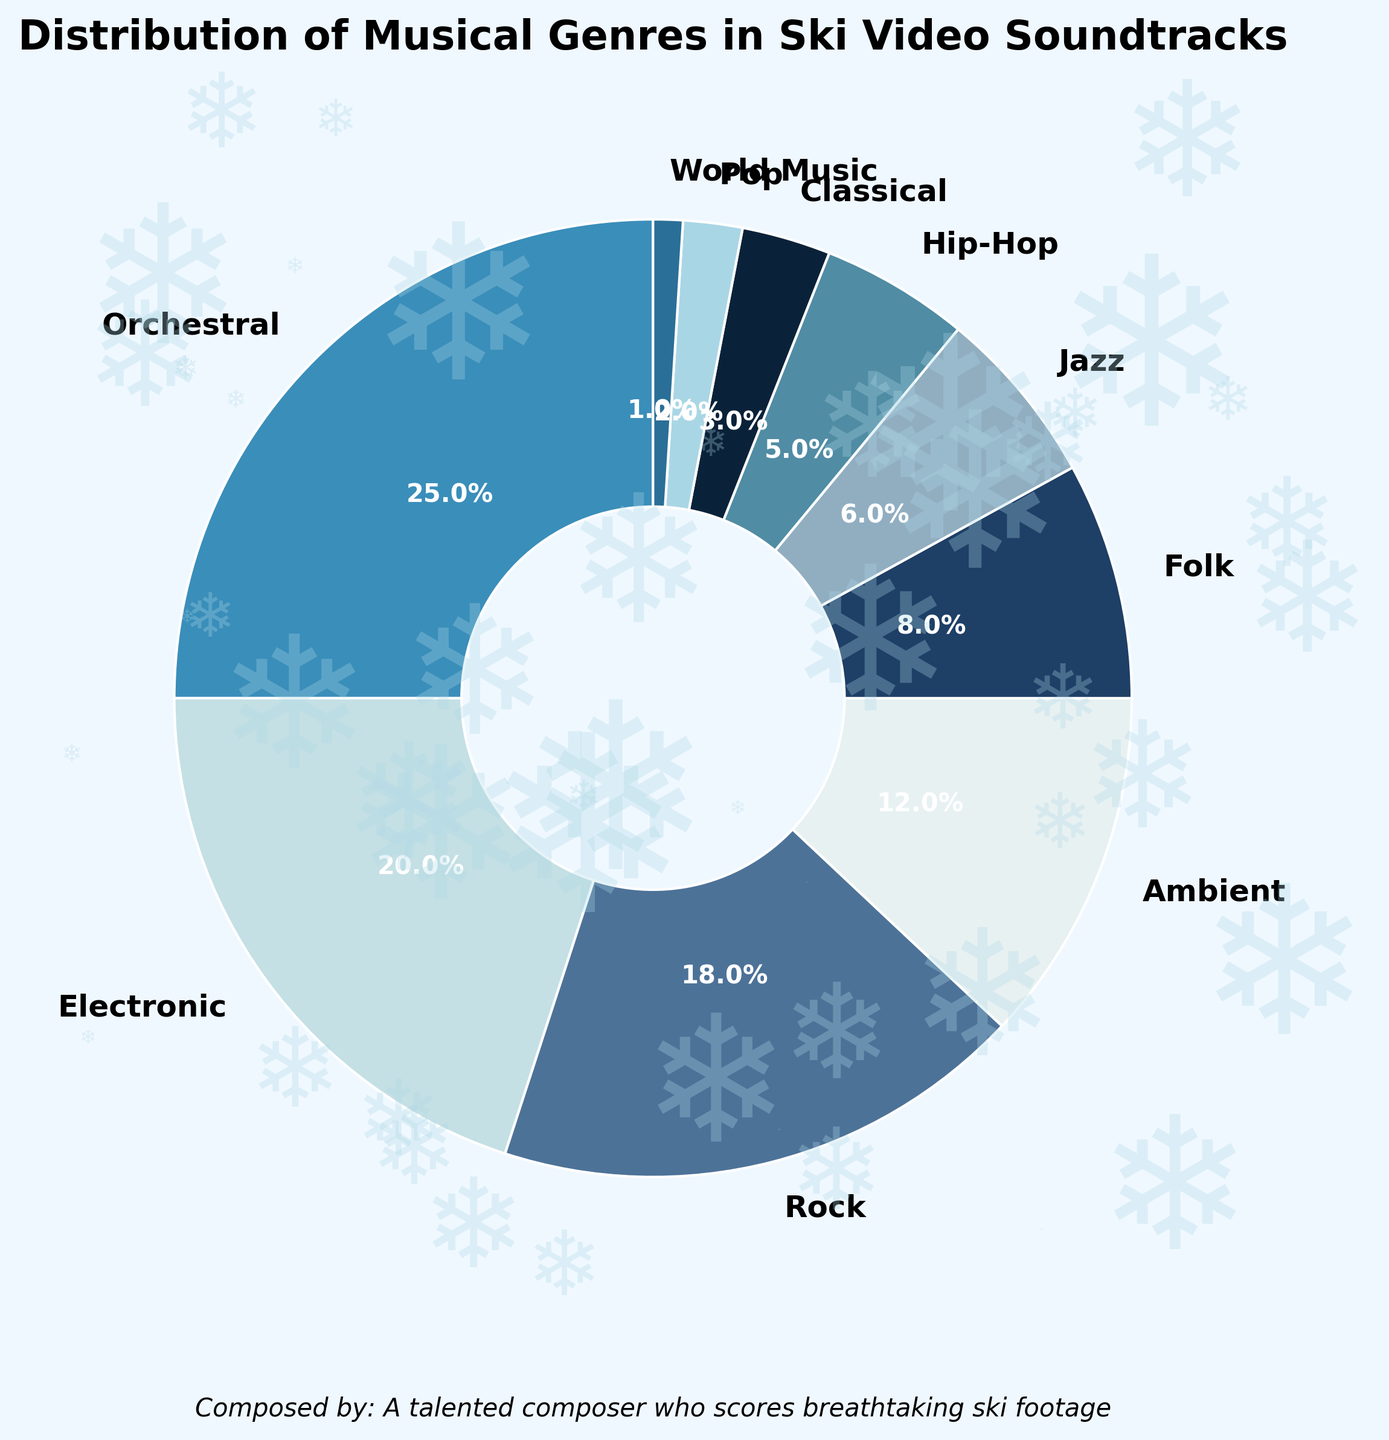What's the most used musical genre in the ski video soundtracks? The pie chart visually highlights that "Orchestral" occupies the largest segment. By checking the percentages, "Orchestral" has 25%.
Answer: Orchestral Which musical genres take up more than 10% each of the total distribution? The pie chart segments representing more than 10% are "Orchestral" (25%), "Electronic" (20%), "Rock" (18%), and "Ambient" (12%), as their values exceed 10%.
Answer: Orchestral, Electronic, Rock, Ambient What is the combined percentage of the least used genres (Hip-Hop, Classical, Pop, World Music)? The percentages for Hip-Hop, Classical, Pop, and World Music are 5%, 3%, 2%, and 1% respectively. Adding these gives 5 + 3 + 2 + 1 = 11%.
Answer: 11% Which genre is represented by the smallest segment in the pie chart? The smallest segment in the pie chart is "World Music" which has a percentage of 1%, making it the least represented.
Answer: World Music How does the percentage of "Jazz" compare to the percentage of "Folk"? "Jazz" has a percentage of 6%, while "Folk" has 8%. Hence, "Folk" has a higher percentage than "Jazz".
Answer: Folk is higher Which color represents the genre "Electronic"? "Electronic" is the second listed genre and its segment in the pie chart is colored with a light blue shade.
Answer: Light blue What is the difference in percentage between the most used and the least used genres? The most used genre, "Orchestral", has 25%, and the least used, "World Music", has 1%. The difference is 25 - 1 = 24%.
Answer: 24% If you combine the percentages of "Folk" and "Jazz", how does it compare to "Rock"? "Folk" is 8%, and "Jazz" is 6%. Combined, they total 8 + 6 = 14%. "Rock" has 18%, so the combined value of "Folk" and "Jazz" (14%) is less than "Rock" (18%).
Answer: Less than Rock What percentage of genres uses orchestral elements (Orchestral and Classical)? Orchestral is 25% and Classical is 3%. Their combined value is 25 + 3 = 28%.
Answer: 28% If the data were to be visualized without "Hip-Hop", what would be the new total percentage of the remaining genres? Excluding "Hip-Hop" which is 5%, the remaining total is 100 - 5 = 95%.
Answer: 95% 